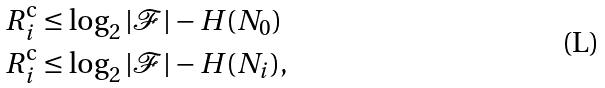Convert formula to latex. <formula><loc_0><loc_0><loc_500><loc_500>R _ { i } ^ { \text {c} } & \leq \log _ { 2 } | \mathcal { F } | - H ( N _ { 0 } ) \\ R _ { i } ^ { \text {c} } & \leq \log _ { 2 } | \mathcal { F } | - H ( N _ { i } ) ,</formula> 